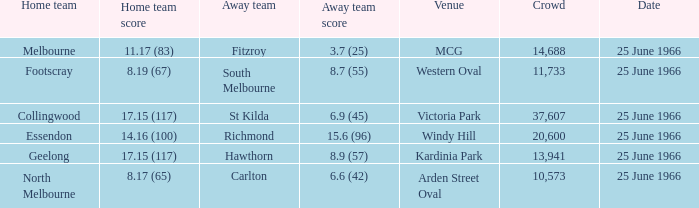Give me the full table as a dictionary. {'header': ['Home team', 'Home team score', 'Away team', 'Away team score', 'Venue', 'Crowd', 'Date'], 'rows': [['Melbourne', '11.17 (83)', 'Fitzroy', '3.7 (25)', 'MCG', '14,688', '25 June 1966'], ['Footscray', '8.19 (67)', 'South Melbourne', '8.7 (55)', 'Western Oval', '11,733', '25 June 1966'], ['Collingwood', '17.15 (117)', 'St Kilda', '6.9 (45)', 'Victoria Park', '37,607', '25 June 1966'], ['Essendon', '14.16 (100)', 'Richmond', '15.6 (96)', 'Windy Hill', '20,600', '25 June 1966'], ['Geelong', '17.15 (117)', 'Hawthorn', '8.9 (57)', 'Kardinia Park', '13,941', '25 June 1966'], ['North Melbourne', '8.17 (65)', 'Carlton', '6.6 (42)', 'Arden Street Oval', '10,573', '25 June 1966']]} Where did the away team score 8.7 (55)? Western Oval. 